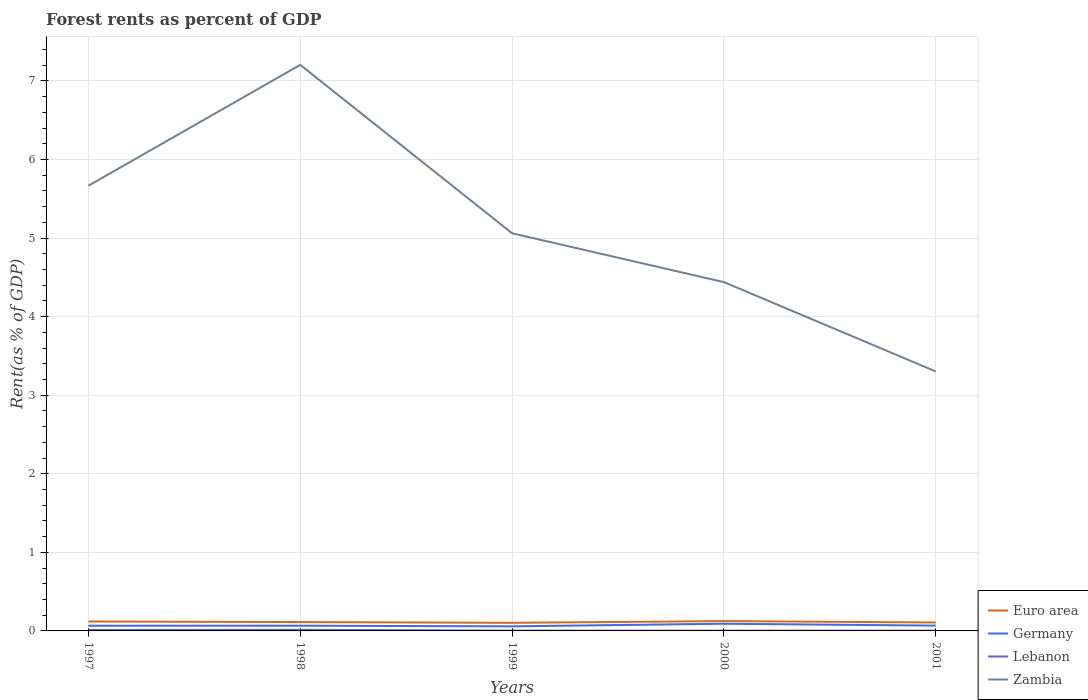How many different coloured lines are there?
Offer a terse response. 4. Is the number of lines equal to the number of legend labels?
Ensure brevity in your answer.  Yes. Across all years, what is the maximum forest rent in Euro area?
Make the answer very short. 0.1. What is the total forest rent in Germany in the graph?
Keep it short and to the point. 0.01. What is the difference between the highest and the second highest forest rent in Zambia?
Ensure brevity in your answer.  3.9. What is the difference between the highest and the lowest forest rent in Germany?
Provide a succinct answer. 1. Is the forest rent in Lebanon strictly greater than the forest rent in Zambia over the years?
Ensure brevity in your answer.  Yes. How many lines are there?
Keep it short and to the point. 4. Are the values on the major ticks of Y-axis written in scientific E-notation?
Offer a very short reply. No. Does the graph contain any zero values?
Provide a succinct answer. No. Does the graph contain grids?
Keep it short and to the point. Yes. Where does the legend appear in the graph?
Ensure brevity in your answer.  Bottom right. How are the legend labels stacked?
Provide a succinct answer. Vertical. What is the title of the graph?
Offer a very short reply. Forest rents as percent of GDP. What is the label or title of the X-axis?
Make the answer very short. Years. What is the label or title of the Y-axis?
Your answer should be compact. Rent(as % of GDP). What is the Rent(as % of GDP) of Euro area in 1997?
Ensure brevity in your answer.  0.12. What is the Rent(as % of GDP) in Germany in 1997?
Make the answer very short. 0.07. What is the Rent(as % of GDP) of Lebanon in 1997?
Offer a very short reply. 0.01. What is the Rent(as % of GDP) of Zambia in 1997?
Provide a short and direct response. 5.67. What is the Rent(as % of GDP) of Euro area in 1998?
Ensure brevity in your answer.  0.11. What is the Rent(as % of GDP) of Germany in 1998?
Your answer should be very brief. 0.07. What is the Rent(as % of GDP) of Lebanon in 1998?
Ensure brevity in your answer.  0.01. What is the Rent(as % of GDP) in Zambia in 1998?
Offer a very short reply. 7.2. What is the Rent(as % of GDP) in Euro area in 1999?
Keep it short and to the point. 0.1. What is the Rent(as % of GDP) in Germany in 1999?
Make the answer very short. 0.06. What is the Rent(as % of GDP) of Lebanon in 1999?
Your answer should be very brief. 0. What is the Rent(as % of GDP) in Zambia in 1999?
Your answer should be compact. 5.06. What is the Rent(as % of GDP) of Euro area in 2000?
Ensure brevity in your answer.  0.13. What is the Rent(as % of GDP) of Germany in 2000?
Your answer should be compact. 0.09. What is the Rent(as % of GDP) of Lebanon in 2000?
Your answer should be very brief. 0. What is the Rent(as % of GDP) in Zambia in 2000?
Ensure brevity in your answer.  4.44. What is the Rent(as % of GDP) in Euro area in 2001?
Provide a short and direct response. 0.11. What is the Rent(as % of GDP) of Germany in 2001?
Give a very brief answer. 0.07. What is the Rent(as % of GDP) of Lebanon in 2001?
Your response must be concise. 0. What is the Rent(as % of GDP) in Zambia in 2001?
Give a very brief answer. 3.3. Across all years, what is the maximum Rent(as % of GDP) of Euro area?
Your response must be concise. 0.13. Across all years, what is the maximum Rent(as % of GDP) of Germany?
Your response must be concise. 0.09. Across all years, what is the maximum Rent(as % of GDP) in Lebanon?
Provide a short and direct response. 0.01. Across all years, what is the maximum Rent(as % of GDP) of Zambia?
Make the answer very short. 7.2. Across all years, what is the minimum Rent(as % of GDP) in Euro area?
Your answer should be very brief. 0.1. Across all years, what is the minimum Rent(as % of GDP) of Germany?
Offer a very short reply. 0.06. Across all years, what is the minimum Rent(as % of GDP) in Lebanon?
Your response must be concise. 0. Across all years, what is the minimum Rent(as % of GDP) in Zambia?
Offer a terse response. 3.3. What is the total Rent(as % of GDP) in Euro area in the graph?
Your answer should be very brief. 0.57. What is the total Rent(as % of GDP) in Germany in the graph?
Provide a short and direct response. 0.35. What is the total Rent(as % of GDP) in Lebanon in the graph?
Ensure brevity in your answer.  0.04. What is the total Rent(as % of GDP) of Zambia in the graph?
Give a very brief answer. 25.67. What is the difference between the Rent(as % of GDP) of Euro area in 1997 and that in 1998?
Give a very brief answer. 0.01. What is the difference between the Rent(as % of GDP) of Germany in 1997 and that in 1998?
Ensure brevity in your answer.  -0. What is the difference between the Rent(as % of GDP) in Lebanon in 1997 and that in 1998?
Give a very brief answer. -0. What is the difference between the Rent(as % of GDP) of Zambia in 1997 and that in 1998?
Keep it short and to the point. -1.54. What is the difference between the Rent(as % of GDP) of Euro area in 1997 and that in 1999?
Keep it short and to the point. 0.02. What is the difference between the Rent(as % of GDP) of Germany in 1997 and that in 1999?
Make the answer very short. 0.01. What is the difference between the Rent(as % of GDP) of Lebanon in 1997 and that in 1999?
Your response must be concise. 0.01. What is the difference between the Rent(as % of GDP) in Zambia in 1997 and that in 1999?
Offer a terse response. 0.6. What is the difference between the Rent(as % of GDP) in Euro area in 1997 and that in 2000?
Ensure brevity in your answer.  -0. What is the difference between the Rent(as % of GDP) of Germany in 1997 and that in 2000?
Your response must be concise. -0.03. What is the difference between the Rent(as % of GDP) in Lebanon in 1997 and that in 2000?
Offer a terse response. 0.01. What is the difference between the Rent(as % of GDP) in Zambia in 1997 and that in 2000?
Your response must be concise. 1.23. What is the difference between the Rent(as % of GDP) in Euro area in 1997 and that in 2001?
Provide a short and direct response. 0.01. What is the difference between the Rent(as % of GDP) in Germany in 1997 and that in 2001?
Provide a succinct answer. -0. What is the difference between the Rent(as % of GDP) in Lebanon in 1997 and that in 2001?
Keep it short and to the point. 0.01. What is the difference between the Rent(as % of GDP) in Zambia in 1997 and that in 2001?
Make the answer very short. 2.36. What is the difference between the Rent(as % of GDP) of Euro area in 1998 and that in 1999?
Provide a short and direct response. 0.01. What is the difference between the Rent(as % of GDP) in Germany in 1998 and that in 1999?
Your answer should be very brief. 0.01. What is the difference between the Rent(as % of GDP) of Lebanon in 1998 and that in 1999?
Offer a very short reply. 0.01. What is the difference between the Rent(as % of GDP) in Zambia in 1998 and that in 1999?
Offer a very short reply. 2.14. What is the difference between the Rent(as % of GDP) in Euro area in 1998 and that in 2000?
Provide a short and direct response. -0.01. What is the difference between the Rent(as % of GDP) in Germany in 1998 and that in 2000?
Your answer should be very brief. -0.03. What is the difference between the Rent(as % of GDP) of Lebanon in 1998 and that in 2000?
Keep it short and to the point. 0.01. What is the difference between the Rent(as % of GDP) in Zambia in 1998 and that in 2000?
Give a very brief answer. 2.77. What is the difference between the Rent(as % of GDP) in Euro area in 1998 and that in 2001?
Ensure brevity in your answer.  0.01. What is the difference between the Rent(as % of GDP) in Germany in 1998 and that in 2001?
Your response must be concise. -0. What is the difference between the Rent(as % of GDP) of Lebanon in 1998 and that in 2001?
Make the answer very short. 0.01. What is the difference between the Rent(as % of GDP) in Zambia in 1998 and that in 2001?
Provide a succinct answer. 3.9. What is the difference between the Rent(as % of GDP) in Euro area in 1999 and that in 2000?
Provide a succinct answer. -0.02. What is the difference between the Rent(as % of GDP) of Germany in 1999 and that in 2000?
Offer a very short reply. -0.03. What is the difference between the Rent(as % of GDP) of Lebanon in 1999 and that in 2000?
Your answer should be compact. 0. What is the difference between the Rent(as % of GDP) in Zambia in 1999 and that in 2000?
Give a very brief answer. 0.62. What is the difference between the Rent(as % of GDP) in Euro area in 1999 and that in 2001?
Your response must be concise. -0. What is the difference between the Rent(as % of GDP) of Germany in 1999 and that in 2001?
Your answer should be compact. -0.01. What is the difference between the Rent(as % of GDP) in Lebanon in 1999 and that in 2001?
Offer a terse response. 0. What is the difference between the Rent(as % of GDP) of Zambia in 1999 and that in 2001?
Make the answer very short. 1.76. What is the difference between the Rent(as % of GDP) of Euro area in 2000 and that in 2001?
Make the answer very short. 0.02. What is the difference between the Rent(as % of GDP) in Germany in 2000 and that in 2001?
Provide a short and direct response. 0.02. What is the difference between the Rent(as % of GDP) of Zambia in 2000 and that in 2001?
Make the answer very short. 1.14. What is the difference between the Rent(as % of GDP) in Euro area in 1997 and the Rent(as % of GDP) in Germany in 1998?
Keep it short and to the point. 0.05. What is the difference between the Rent(as % of GDP) in Euro area in 1997 and the Rent(as % of GDP) in Lebanon in 1998?
Offer a terse response. 0.11. What is the difference between the Rent(as % of GDP) of Euro area in 1997 and the Rent(as % of GDP) of Zambia in 1998?
Keep it short and to the point. -7.08. What is the difference between the Rent(as % of GDP) of Germany in 1997 and the Rent(as % of GDP) of Lebanon in 1998?
Provide a short and direct response. 0.05. What is the difference between the Rent(as % of GDP) in Germany in 1997 and the Rent(as % of GDP) in Zambia in 1998?
Make the answer very short. -7.14. What is the difference between the Rent(as % of GDP) in Lebanon in 1997 and the Rent(as % of GDP) in Zambia in 1998?
Provide a short and direct response. -7.19. What is the difference between the Rent(as % of GDP) of Euro area in 1997 and the Rent(as % of GDP) of Germany in 1999?
Give a very brief answer. 0.06. What is the difference between the Rent(as % of GDP) in Euro area in 1997 and the Rent(as % of GDP) in Lebanon in 1999?
Provide a succinct answer. 0.12. What is the difference between the Rent(as % of GDP) of Euro area in 1997 and the Rent(as % of GDP) of Zambia in 1999?
Give a very brief answer. -4.94. What is the difference between the Rent(as % of GDP) of Germany in 1997 and the Rent(as % of GDP) of Lebanon in 1999?
Your answer should be compact. 0.06. What is the difference between the Rent(as % of GDP) of Germany in 1997 and the Rent(as % of GDP) of Zambia in 1999?
Your answer should be very brief. -5. What is the difference between the Rent(as % of GDP) in Lebanon in 1997 and the Rent(as % of GDP) in Zambia in 1999?
Give a very brief answer. -5.05. What is the difference between the Rent(as % of GDP) in Euro area in 1997 and the Rent(as % of GDP) in Germany in 2000?
Your answer should be compact. 0.03. What is the difference between the Rent(as % of GDP) of Euro area in 1997 and the Rent(as % of GDP) of Lebanon in 2000?
Provide a succinct answer. 0.12. What is the difference between the Rent(as % of GDP) in Euro area in 1997 and the Rent(as % of GDP) in Zambia in 2000?
Make the answer very short. -4.32. What is the difference between the Rent(as % of GDP) in Germany in 1997 and the Rent(as % of GDP) in Lebanon in 2000?
Give a very brief answer. 0.06. What is the difference between the Rent(as % of GDP) of Germany in 1997 and the Rent(as % of GDP) of Zambia in 2000?
Offer a very short reply. -4.37. What is the difference between the Rent(as % of GDP) in Lebanon in 1997 and the Rent(as % of GDP) in Zambia in 2000?
Give a very brief answer. -4.43. What is the difference between the Rent(as % of GDP) in Euro area in 1997 and the Rent(as % of GDP) in Germany in 2001?
Provide a short and direct response. 0.05. What is the difference between the Rent(as % of GDP) in Euro area in 1997 and the Rent(as % of GDP) in Lebanon in 2001?
Your answer should be compact. 0.12. What is the difference between the Rent(as % of GDP) of Euro area in 1997 and the Rent(as % of GDP) of Zambia in 2001?
Offer a very short reply. -3.18. What is the difference between the Rent(as % of GDP) of Germany in 1997 and the Rent(as % of GDP) of Lebanon in 2001?
Offer a very short reply. 0.06. What is the difference between the Rent(as % of GDP) in Germany in 1997 and the Rent(as % of GDP) in Zambia in 2001?
Your answer should be compact. -3.24. What is the difference between the Rent(as % of GDP) of Lebanon in 1997 and the Rent(as % of GDP) of Zambia in 2001?
Provide a succinct answer. -3.29. What is the difference between the Rent(as % of GDP) of Euro area in 1998 and the Rent(as % of GDP) of Germany in 1999?
Offer a terse response. 0.05. What is the difference between the Rent(as % of GDP) of Euro area in 1998 and the Rent(as % of GDP) of Lebanon in 1999?
Give a very brief answer. 0.11. What is the difference between the Rent(as % of GDP) in Euro area in 1998 and the Rent(as % of GDP) in Zambia in 1999?
Ensure brevity in your answer.  -4.95. What is the difference between the Rent(as % of GDP) in Germany in 1998 and the Rent(as % of GDP) in Lebanon in 1999?
Your answer should be very brief. 0.06. What is the difference between the Rent(as % of GDP) in Germany in 1998 and the Rent(as % of GDP) in Zambia in 1999?
Keep it short and to the point. -5. What is the difference between the Rent(as % of GDP) in Lebanon in 1998 and the Rent(as % of GDP) in Zambia in 1999?
Ensure brevity in your answer.  -5.05. What is the difference between the Rent(as % of GDP) of Euro area in 1998 and the Rent(as % of GDP) of Germany in 2000?
Your answer should be compact. 0.02. What is the difference between the Rent(as % of GDP) in Euro area in 1998 and the Rent(as % of GDP) in Lebanon in 2000?
Keep it short and to the point. 0.11. What is the difference between the Rent(as % of GDP) of Euro area in 1998 and the Rent(as % of GDP) of Zambia in 2000?
Make the answer very short. -4.33. What is the difference between the Rent(as % of GDP) in Germany in 1998 and the Rent(as % of GDP) in Lebanon in 2000?
Your answer should be compact. 0.06. What is the difference between the Rent(as % of GDP) of Germany in 1998 and the Rent(as % of GDP) of Zambia in 2000?
Provide a short and direct response. -4.37. What is the difference between the Rent(as % of GDP) of Lebanon in 1998 and the Rent(as % of GDP) of Zambia in 2000?
Your response must be concise. -4.43. What is the difference between the Rent(as % of GDP) of Euro area in 1998 and the Rent(as % of GDP) of Germany in 2001?
Make the answer very short. 0.05. What is the difference between the Rent(as % of GDP) of Euro area in 1998 and the Rent(as % of GDP) of Lebanon in 2001?
Provide a succinct answer. 0.11. What is the difference between the Rent(as % of GDP) of Euro area in 1998 and the Rent(as % of GDP) of Zambia in 2001?
Give a very brief answer. -3.19. What is the difference between the Rent(as % of GDP) of Germany in 1998 and the Rent(as % of GDP) of Lebanon in 2001?
Provide a succinct answer. 0.06. What is the difference between the Rent(as % of GDP) of Germany in 1998 and the Rent(as % of GDP) of Zambia in 2001?
Ensure brevity in your answer.  -3.24. What is the difference between the Rent(as % of GDP) of Lebanon in 1998 and the Rent(as % of GDP) of Zambia in 2001?
Provide a succinct answer. -3.29. What is the difference between the Rent(as % of GDP) in Euro area in 1999 and the Rent(as % of GDP) in Germany in 2000?
Provide a short and direct response. 0.01. What is the difference between the Rent(as % of GDP) in Euro area in 1999 and the Rent(as % of GDP) in Lebanon in 2000?
Offer a very short reply. 0.1. What is the difference between the Rent(as % of GDP) in Euro area in 1999 and the Rent(as % of GDP) in Zambia in 2000?
Your answer should be compact. -4.34. What is the difference between the Rent(as % of GDP) in Germany in 1999 and the Rent(as % of GDP) in Lebanon in 2000?
Provide a succinct answer. 0.05. What is the difference between the Rent(as % of GDP) in Germany in 1999 and the Rent(as % of GDP) in Zambia in 2000?
Offer a terse response. -4.38. What is the difference between the Rent(as % of GDP) in Lebanon in 1999 and the Rent(as % of GDP) in Zambia in 2000?
Provide a short and direct response. -4.44. What is the difference between the Rent(as % of GDP) in Euro area in 1999 and the Rent(as % of GDP) in Germany in 2001?
Keep it short and to the point. 0.04. What is the difference between the Rent(as % of GDP) of Euro area in 1999 and the Rent(as % of GDP) of Lebanon in 2001?
Offer a very short reply. 0.1. What is the difference between the Rent(as % of GDP) in Euro area in 1999 and the Rent(as % of GDP) in Zambia in 2001?
Give a very brief answer. -3.2. What is the difference between the Rent(as % of GDP) in Germany in 1999 and the Rent(as % of GDP) in Lebanon in 2001?
Provide a short and direct response. 0.05. What is the difference between the Rent(as % of GDP) of Germany in 1999 and the Rent(as % of GDP) of Zambia in 2001?
Your answer should be compact. -3.24. What is the difference between the Rent(as % of GDP) in Lebanon in 1999 and the Rent(as % of GDP) in Zambia in 2001?
Provide a short and direct response. -3.3. What is the difference between the Rent(as % of GDP) of Euro area in 2000 and the Rent(as % of GDP) of Germany in 2001?
Your answer should be compact. 0.06. What is the difference between the Rent(as % of GDP) of Euro area in 2000 and the Rent(as % of GDP) of Lebanon in 2001?
Provide a succinct answer. 0.12. What is the difference between the Rent(as % of GDP) of Euro area in 2000 and the Rent(as % of GDP) of Zambia in 2001?
Provide a short and direct response. -3.18. What is the difference between the Rent(as % of GDP) in Germany in 2000 and the Rent(as % of GDP) in Lebanon in 2001?
Give a very brief answer. 0.09. What is the difference between the Rent(as % of GDP) in Germany in 2000 and the Rent(as % of GDP) in Zambia in 2001?
Ensure brevity in your answer.  -3.21. What is the difference between the Rent(as % of GDP) in Lebanon in 2000 and the Rent(as % of GDP) in Zambia in 2001?
Offer a terse response. -3.3. What is the average Rent(as % of GDP) of Euro area per year?
Your answer should be compact. 0.11. What is the average Rent(as % of GDP) in Germany per year?
Offer a terse response. 0.07. What is the average Rent(as % of GDP) in Lebanon per year?
Offer a terse response. 0.01. What is the average Rent(as % of GDP) of Zambia per year?
Make the answer very short. 5.13. In the year 1997, what is the difference between the Rent(as % of GDP) of Euro area and Rent(as % of GDP) of Germany?
Ensure brevity in your answer.  0.05. In the year 1997, what is the difference between the Rent(as % of GDP) of Euro area and Rent(as % of GDP) of Lebanon?
Offer a terse response. 0.11. In the year 1997, what is the difference between the Rent(as % of GDP) of Euro area and Rent(as % of GDP) of Zambia?
Provide a short and direct response. -5.55. In the year 1997, what is the difference between the Rent(as % of GDP) of Germany and Rent(as % of GDP) of Lebanon?
Make the answer very short. 0.05. In the year 1997, what is the difference between the Rent(as % of GDP) in Germany and Rent(as % of GDP) in Zambia?
Your answer should be very brief. -5.6. In the year 1997, what is the difference between the Rent(as % of GDP) of Lebanon and Rent(as % of GDP) of Zambia?
Make the answer very short. -5.65. In the year 1998, what is the difference between the Rent(as % of GDP) in Euro area and Rent(as % of GDP) in Germany?
Your response must be concise. 0.05. In the year 1998, what is the difference between the Rent(as % of GDP) in Euro area and Rent(as % of GDP) in Lebanon?
Keep it short and to the point. 0.1. In the year 1998, what is the difference between the Rent(as % of GDP) in Euro area and Rent(as % of GDP) in Zambia?
Your answer should be very brief. -7.09. In the year 1998, what is the difference between the Rent(as % of GDP) of Germany and Rent(as % of GDP) of Lebanon?
Your answer should be very brief. 0.05. In the year 1998, what is the difference between the Rent(as % of GDP) in Germany and Rent(as % of GDP) in Zambia?
Give a very brief answer. -7.14. In the year 1998, what is the difference between the Rent(as % of GDP) of Lebanon and Rent(as % of GDP) of Zambia?
Provide a short and direct response. -7.19. In the year 1999, what is the difference between the Rent(as % of GDP) of Euro area and Rent(as % of GDP) of Germany?
Give a very brief answer. 0.05. In the year 1999, what is the difference between the Rent(as % of GDP) of Euro area and Rent(as % of GDP) of Lebanon?
Make the answer very short. 0.1. In the year 1999, what is the difference between the Rent(as % of GDP) in Euro area and Rent(as % of GDP) in Zambia?
Give a very brief answer. -4.96. In the year 1999, what is the difference between the Rent(as % of GDP) in Germany and Rent(as % of GDP) in Lebanon?
Your answer should be compact. 0.05. In the year 1999, what is the difference between the Rent(as % of GDP) of Germany and Rent(as % of GDP) of Zambia?
Give a very brief answer. -5. In the year 1999, what is the difference between the Rent(as % of GDP) of Lebanon and Rent(as % of GDP) of Zambia?
Your response must be concise. -5.06. In the year 2000, what is the difference between the Rent(as % of GDP) of Euro area and Rent(as % of GDP) of Germany?
Ensure brevity in your answer.  0.03. In the year 2000, what is the difference between the Rent(as % of GDP) of Euro area and Rent(as % of GDP) of Lebanon?
Give a very brief answer. 0.12. In the year 2000, what is the difference between the Rent(as % of GDP) in Euro area and Rent(as % of GDP) in Zambia?
Offer a terse response. -4.31. In the year 2000, what is the difference between the Rent(as % of GDP) in Germany and Rent(as % of GDP) in Lebanon?
Provide a short and direct response. 0.09. In the year 2000, what is the difference between the Rent(as % of GDP) in Germany and Rent(as % of GDP) in Zambia?
Your answer should be compact. -4.35. In the year 2000, what is the difference between the Rent(as % of GDP) in Lebanon and Rent(as % of GDP) in Zambia?
Offer a terse response. -4.44. In the year 2001, what is the difference between the Rent(as % of GDP) in Euro area and Rent(as % of GDP) in Germany?
Offer a very short reply. 0.04. In the year 2001, what is the difference between the Rent(as % of GDP) of Euro area and Rent(as % of GDP) of Lebanon?
Your answer should be compact. 0.1. In the year 2001, what is the difference between the Rent(as % of GDP) in Euro area and Rent(as % of GDP) in Zambia?
Your response must be concise. -3.2. In the year 2001, what is the difference between the Rent(as % of GDP) in Germany and Rent(as % of GDP) in Lebanon?
Provide a short and direct response. 0.06. In the year 2001, what is the difference between the Rent(as % of GDP) in Germany and Rent(as % of GDP) in Zambia?
Offer a very short reply. -3.24. In the year 2001, what is the difference between the Rent(as % of GDP) in Lebanon and Rent(as % of GDP) in Zambia?
Keep it short and to the point. -3.3. What is the ratio of the Rent(as % of GDP) in Euro area in 1997 to that in 1998?
Offer a very short reply. 1.07. What is the ratio of the Rent(as % of GDP) of Germany in 1997 to that in 1998?
Keep it short and to the point. 1. What is the ratio of the Rent(as % of GDP) of Lebanon in 1997 to that in 1998?
Keep it short and to the point. 0.87. What is the ratio of the Rent(as % of GDP) in Zambia in 1997 to that in 1998?
Your answer should be very brief. 0.79. What is the ratio of the Rent(as % of GDP) of Euro area in 1997 to that in 1999?
Make the answer very short. 1.16. What is the ratio of the Rent(as % of GDP) of Germany in 1997 to that in 1999?
Keep it short and to the point. 1.14. What is the ratio of the Rent(as % of GDP) in Lebanon in 1997 to that in 1999?
Provide a succinct answer. 3.23. What is the ratio of the Rent(as % of GDP) in Zambia in 1997 to that in 1999?
Make the answer very short. 1.12. What is the ratio of the Rent(as % of GDP) of Euro area in 1997 to that in 2000?
Ensure brevity in your answer.  0.96. What is the ratio of the Rent(as % of GDP) in Germany in 1997 to that in 2000?
Your answer should be very brief. 0.72. What is the ratio of the Rent(as % of GDP) in Lebanon in 1997 to that in 2000?
Make the answer very short. 3.45. What is the ratio of the Rent(as % of GDP) of Zambia in 1997 to that in 2000?
Ensure brevity in your answer.  1.28. What is the ratio of the Rent(as % of GDP) in Euro area in 1997 to that in 2001?
Ensure brevity in your answer.  1.12. What is the ratio of the Rent(as % of GDP) of Germany in 1997 to that in 2001?
Make the answer very short. 0.98. What is the ratio of the Rent(as % of GDP) in Lebanon in 1997 to that in 2001?
Give a very brief answer. 3.45. What is the ratio of the Rent(as % of GDP) of Zambia in 1997 to that in 2001?
Offer a terse response. 1.72. What is the ratio of the Rent(as % of GDP) of Euro area in 1998 to that in 1999?
Make the answer very short. 1.09. What is the ratio of the Rent(as % of GDP) of Germany in 1998 to that in 1999?
Your response must be concise. 1.14. What is the ratio of the Rent(as % of GDP) in Lebanon in 1998 to that in 1999?
Give a very brief answer. 3.69. What is the ratio of the Rent(as % of GDP) of Zambia in 1998 to that in 1999?
Provide a succinct answer. 1.42. What is the ratio of the Rent(as % of GDP) of Euro area in 1998 to that in 2000?
Your answer should be very brief. 0.9. What is the ratio of the Rent(as % of GDP) of Germany in 1998 to that in 2000?
Keep it short and to the point. 0.73. What is the ratio of the Rent(as % of GDP) of Lebanon in 1998 to that in 2000?
Give a very brief answer. 3.95. What is the ratio of the Rent(as % of GDP) of Zambia in 1998 to that in 2000?
Provide a succinct answer. 1.62. What is the ratio of the Rent(as % of GDP) in Euro area in 1998 to that in 2001?
Make the answer very short. 1.05. What is the ratio of the Rent(as % of GDP) in Germany in 1998 to that in 2001?
Give a very brief answer. 0.98. What is the ratio of the Rent(as % of GDP) of Lebanon in 1998 to that in 2001?
Offer a very short reply. 3.94. What is the ratio of the Rent(as % of GDP) of Zambia in 1998 to that in 2001?
Ensure brevity in your answer.  2.18. What is the ratio of the Rent(as % of GDP) in Euro area in 1999 to that in 2000?
Give a very brief answer. 0.83. What is the ratio of the Rent(as % of GDP) of Germany in 1999 to that in 2000?
Keep it short and to the point. 0.64. What is the ratio of the Rent(as % of GDP) of Lebanon in 1999 to that in 2000?
Give a very brief answer. 1.07. What is the ratio of the Rent(as % of GDP) of Zambia in 1999 to that in 2000?
Make the answer very short. 1.14. What is the ratio of the Rent(as % of GDP) of Euro area in 1999 to that in 2001?
Offer a very short reply. 0.96. What is the ratio of the Rent(as % of GDP) of Germany in 1999 to that in 2001?
Keep it short and to the point. 0.86. What is the ratio of the Rent(as % of GDP) in Lebanon in 1999 to that in 2001?
Your answer should be compact. 1.07. What is the ratio of the Rent(as % of GDP) in Zambia in 1999 to that in 2001?
Ensure brevity in your answer.  1.53. What is the ratio of the Rent(as % of GDP) in Euro area in 2000 to that in 2001?
Your answer should be compact. 1.16. What is the ratio of the Rent(as % of GDP) in Germany in 2000 to that in 2001?
Provide a succinct answer. 1.36. What is the ratio of the Rent(as % of GDP) of Zambia in 2000 to that in 2001?
Provide a short and direct response. 1.34. What is the difference between the highest and the second highest Rent(as % of GDP) of Euro area?
Your response must be concise. 0. What is the difference between the highest and the second highest Rent(as % of GDP) in Germany?
Provide a succinct answer. 0.02. What is the difference between the highest and the second highest Rent(as % of GDP) in Lebanon?
Provide a succinct answer. 0. What is the difference between the highest and the second highest Rent(as % of GDP) of Zambia?
Ensure brevity in your answer.  1.54. What is the difference between the highest and the lowest Rent(as % of GDP) of Euro area?
Provide a succinct answer. 0.02. What is the difference between the highest and the lowest Rent(as % of GDP) of Germany?
Provide a succinct answer. 0.03. What is the difference between the highest and the lowest Rent(as % of GDP) in Lebanon?
Provide a succinct answer. 0.01. What is the difference between the highest and the lowest Rent(as % of GDP) of Zambia?
Keep it short and to the point. 3.9. 